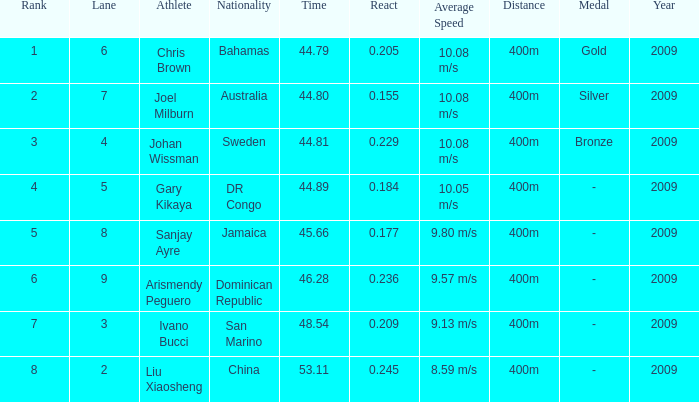What is the total average for Rank entries where the Lane listed is smaller than 4 and the Nationality listed is San Marino? 7.0. 